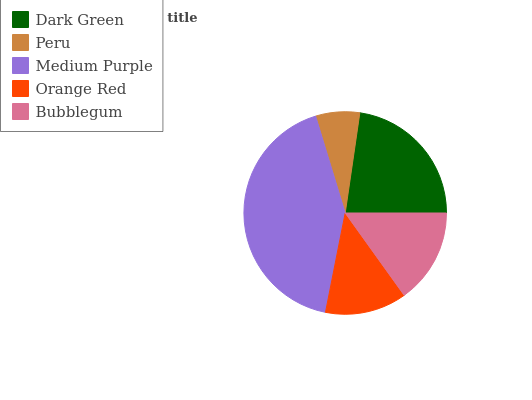Is Peru the minimum?
Answer yes or no. Yes. Is Medium Purple the maximum?
Answer yes or no. Yes. Is Medium Purple the minimum?
Answer yes or no. No. Is Peru the maximum?
Answer yes or no. No. Is Medium Purple greater than Peru?
Answer yes or no. Yes. Is Peru less than Medium Purple?
Answer yes or no. Yes. Is Peru greater than Medium Purple?
Answer yes or no. No. Is Medium Purple less than Peru?
Answer yes or no. No. Is Bubblegum the high median?
Answer yes or no. Yes. Is Bubblegum the low median?
Answer yes or no. Yes. Is Peru the high median?
Answer yes or no. No. Is Dark Green the low median?
Answer yes or no. No. 